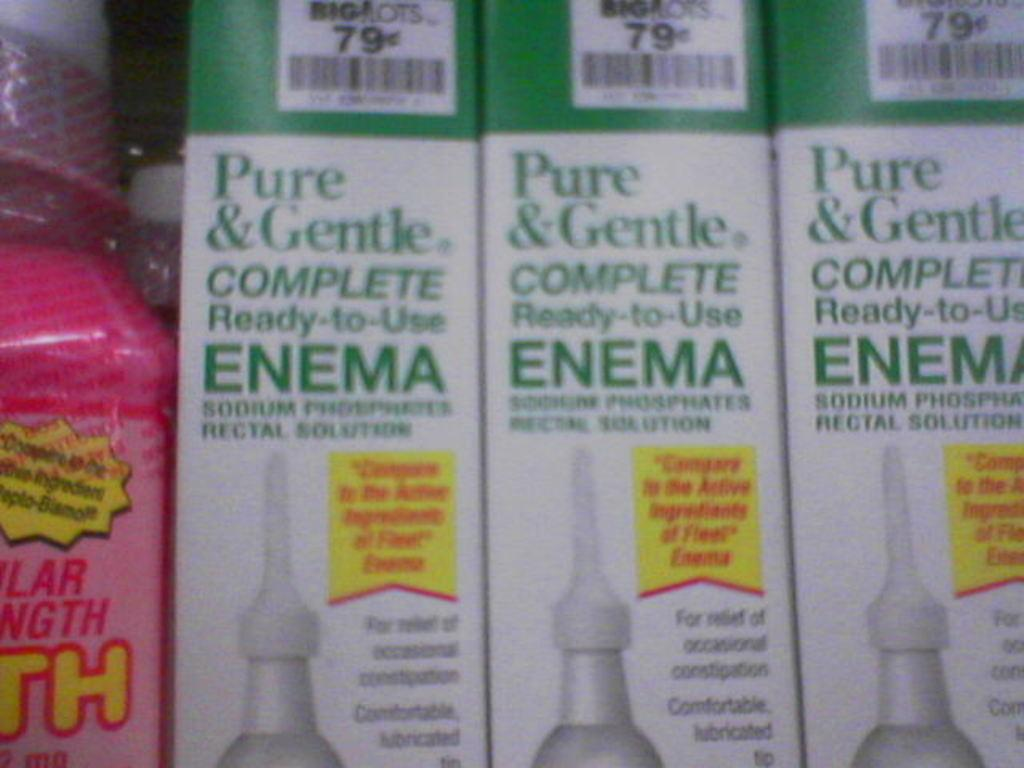<image>
Offer a succinct explanation of the picture presented. Boxes of enemas are lined up together next to a pink bottle.. 